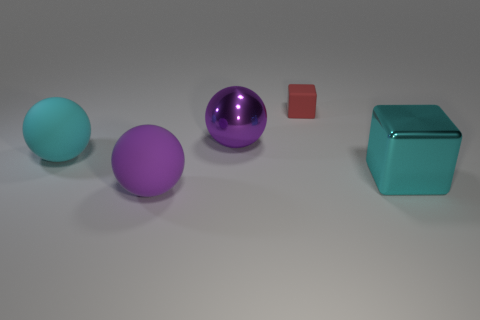Subtract all yellow cubes. Subtract all red spheres. How many cubes are left? 2 Add 2 big blue shiny blocks. How many objects exist? 7 Subtract all blocks. How many objects are left? 3 Subtract 0 yellow blocks. How many objects are left? 5 Subtract all big cyan objects. Subtract all purple matte objects. How many objects are left? 2 Add 5 cyan cubes. How many cyan cubes are left? 6 Add 2 cyan matte things. How many cyan matte things exist? 3 